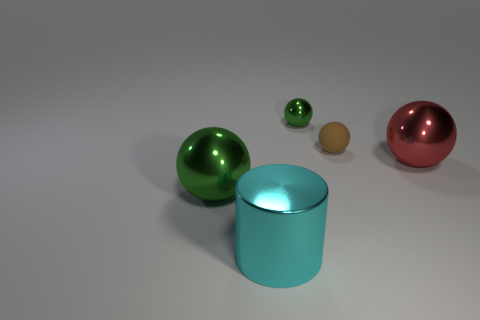What number of things are big metallic spheres that are to the left of the matte sphere or spheres?
Ensure brevity in your answer.  4. Is the color of the big cylinder the same as the tiny rubber thing?
Give a very brief answer. No. What number of other things are there of the same shape as the tiny matte thing?
Provide a succinct answer. 3. What number of cyan things are either metal spheres or metal cylinders?
Provide a short and direct response. 1. The large ball that is made of the same material as the big green thing is what color?
Keep it short and to the point. Red. Is the sphere in front of the large red sphere made of the same material as the brown thing behind the large red metal thing?
Provide a succinct answer. No. The ball that is the same color as the tiny metal thing is what size?
Offer a terse response. Large. What is the material of the large red ball in front of the tiny metallic object?
Ensure brevity in your answer.  Metal. There is a shiny thing behind the big red ball; is it the same shape as the large metallic thing left of the cyan metal thing?
Your answer should be compact. Yes. What material is the other ball that is the same color as the tiny metallic sphere?
Offer a terse response. Metal. 